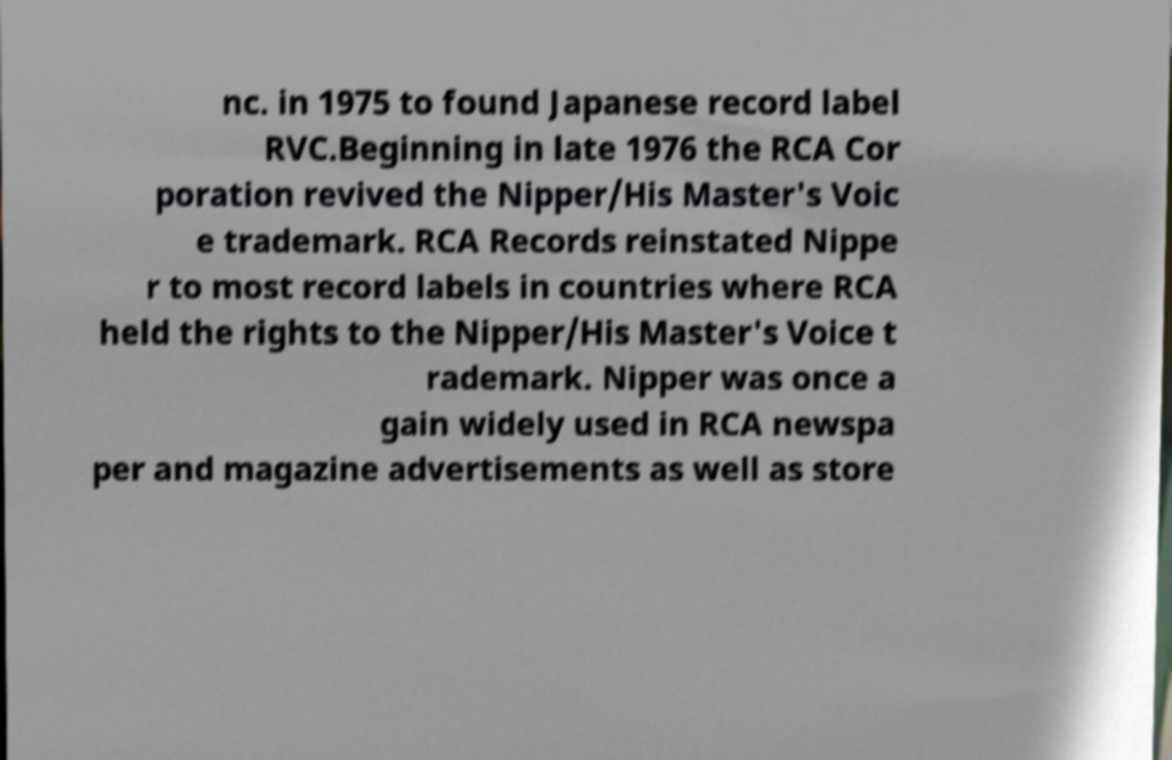Please identify and transcribe the text found in this image. nc. in 1975 to found Japanese record label RVC.Beginning in late 1976 the RCA Cor poration revived the Nipper/His Master's Voic e trademark. RCA Records reinstated Nippe r to most record labels in countries where RCA held the rights to the Nipper/His Master's Voice t rademark. Nipper was once a gain widely used in RCA newspa per and magazine advertisements as well as store 